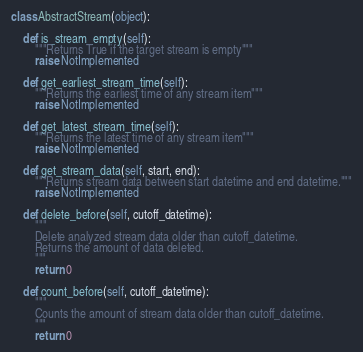<code> <loc_0><loc_0><loc_500><loc_500><_Python_>
class AbstractStream(object):

    def is_stream_empty(self):
        """Returns True if the target stream is empty"""
        raise NotImplemented

    def get_earliest_stream_time(self):
        """Returns the earliest time of any stream item"""
        raise NotImplemented

    def get_latest_stream_time(self):
        """Returns the latest time of any stream item"""
        raise NotImplemented

    def get_stream_data(self, start, end):
        """Returns stream data between start datetime and end datetime."""
        raise NotImplemented

    def delete_before(self, cutoff_datetime):
        """
        Delete analyzed stream data older than cutoff_datetime.
        Returns the amount of data deleted.
        """
        return 0

    def count_before(self, cutoff_datetime):
        """
        Counts the amount of stream data older than cutoff_datetime.
        """
        return 0
</code> 